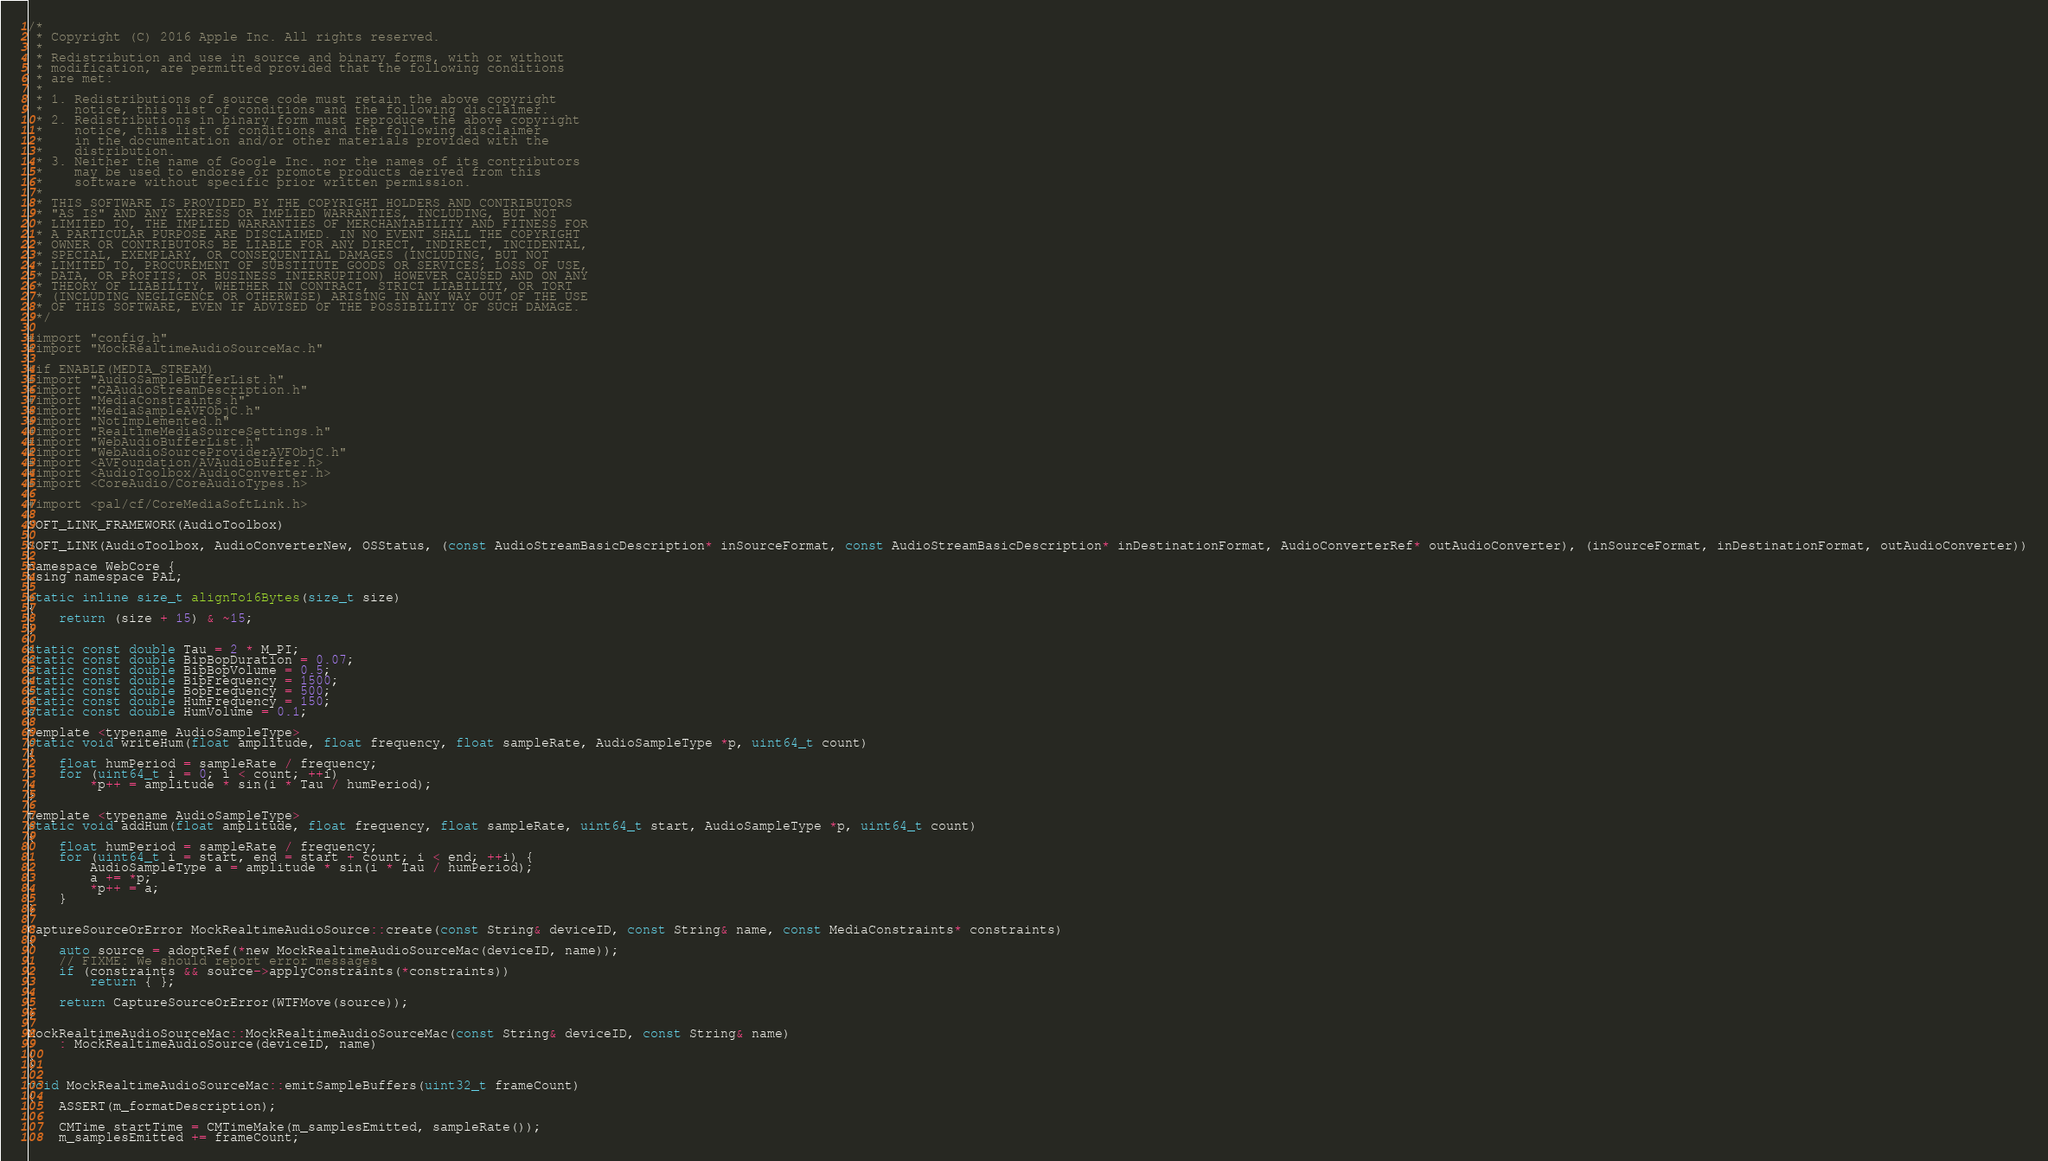Convert code to text. <code><loc_0><loc_0><loc_500><loc_500><_ObjectiveC_>/*
 * Copyright (C) 2016 Apple Inc. All rights reserved.
 *
 * Redistribution and use in source and binary forms, with or without
 * modification, are permitted provided that the following conditions
 * are met:
 *
 * 1. Redistributions of source code must retain the above copyright
 *    notice, this list of conditions and the following disclaimer.
 * 2. Redistributions in binary form must reproduce the above copyright
 *    notice, this list of conditions and the following disclaimer
 *    in the documentation and/or other materials provided with the
 *    distribution.
 * 3. Neither the name of Google Inc. nor the names of its contributors
 *    may be used to endorse or promote products derived from this
 *    software without specific prior written permission.
 *
 * THIS SOFTWARE IS PROVIDED BY THE COPYRIGHT HOLDERS AND CONTRIBUTORS
 * "AS IS" AND ANY EXPRESS OR IMPLIED WARRANTIES, INCLUDING, BUT NOT
 * LIMITED TO, THE IMPLIED WARRANTIES OF MERCHANTABILITY AND FITNESS FOR
 * A PARTICULAR PURPOSE ARE DISCLAIMED. IN NO EVENT SHALL THE COPYRIGHT
 * OWNER OR CONTRIBUTORS BE LIABLE FOR ANY DIRECT, INDIRECT, INCIDENTAL,
 * SPECIAL, EXEMPLARY, OR CONSEQUENTIAL DAMAGES (INCLUDING, BUT NOT
 * LIMITED TO, PROCUREMENT OF SUBSTITUTE GOODS OR SERVICES; LOSS OF USE,
 * DATA, OR PROFITS; OR BUSINESS INTERRUPTION) HOWEVER CAUSED AND ON ANY
 * THEORY OF LIABILITY, WHETHER IN CONTRACT, STRICT LIABILITY, OR TORT
 * (INCLUDING NEGLIGENCE OR OTHERWISE) ARISING IN ANY WAY OUT OF THE USE
 * OF THIS SOFTWARE, EVEN IF ADVISED OF THE POSSIBILITY OF SUCH DAMAGE.
 */

#import "config.h"
#import "MockRealtimeAudioSourceMac.h"

#if ENABLE(MEDIA_STREAM)
#import "AudioSampleBufferList.h"
#import "CAAudioStreamDescription.h"
#import "MediaConstraints.h"
#import "MediaSampleAVFObjC.h"
#import "NotImplemented.h"
#import "RealtimeMediaSourceSettings.h"
#import "WebAudioBufferList.h"
#import "WebAudioSourceProviderAVFObjC.h"
#import <AVFoundation/AVAudioBuffer.h>
#import <AudioToolbox/AudioConverter.h>
#import <CoreAudio/CoreAudioTypes.h>

#import <pal/cf/CoreMediaSoftLink.h>

SOFT_LINK_FRAMEWORK(AudioToolbox)

SOFT_LINK(AudioToolbox, AudioConverterNew, OSStatus, (const AudioStreamBasicDescription* inSourceFormat, const AudioStreamBasicDescription* inDestinationFormat, AudioConverterRef* outAudioConverter), (inSourceFormat, inDestinationFormat, outAudioConverter))

namespace WebCore {
using namespace PAL;

static inline size_t alignTo16Bytes(size_t size)
{
    return (size + 15) & ~15;
}

static const double Tau = 2 * M_PI;
static const double BipBopDuration = 0.07;
static const double BipBopVolume = 0.5;
static const double BipFrequency = 1500;
static const double BopFrequency = 500;
static const double HumFrequency = 150;
static const double HumVolume = 0.1;

template <typename AudioSampleType>
static void writeHum(float amplitude, float frequency, float sampleRate, AudioSampleType *p, uint64_t count)
{
    float humPeriod = sampleRate / frequency;
    for (uint64_t i = 0; i < count; ++i)
        *p++ = amplitude * sin(i * Tau / humPeriod);
}

template <typename AudioSampleType>
static void addHum(float amplitude, float frequency, float sampleRate, uint64_t start, AudioSampleType *p, uint64_t count)
{
    float humPeriod = sampleRate / frequency;
    for (uint64_t i = start, end = start + count; i < end; ++i) {
        AudioSampleType a = amplitude * sin(i * Tau / humPeriod);
        a += *p;
        *p++ = a;
    }
}

CaptureSourceOrError MockRealtimeAudioSource::create(const String& deviceID, const String& name, const MediaConstraints* constraints)
{
    auto source = adoptRef(*new MockRealtimeAudioSourceMac(deviceID, name));
    // FIXME: We should report error messages
    if (constraints && source->applyConstraints(*constraints))
        return { };

    return CaptureSourceOrError(WTFMove(source));
}

MockRealtimeAudioSourceMac::MockRealtimeAudioSourceMac(const String& deviceID, const String& name)
    : MockRealtimeAudioSource(deviceID, name)
{
}

void MockRealtimeAudioSourceMac::emitSampleBuffers(uint32_t frameCount)
{
    ASSERT(m_formatDescription);

    CMTime startTime = CMTimeMake(m_samplesEmitted, sampleRate());
    m_samplesEmitted += frameCount;
</code> 